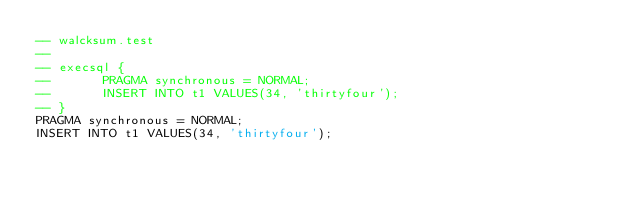<code> <loc_0><loc_0><loc_500><loc_500><_SQL_>-- walcksum.test
-- 
-- execsql { 
--       PRAGMA synchronous = NORMAL;
--       INSERT INTO t1 VALUES(34, 'thirtyfour');
-- }
PRAGMA synchronous = NORMAL;
INSERT INTO t1 VALUES(34, 'thirtyfour');</code> 